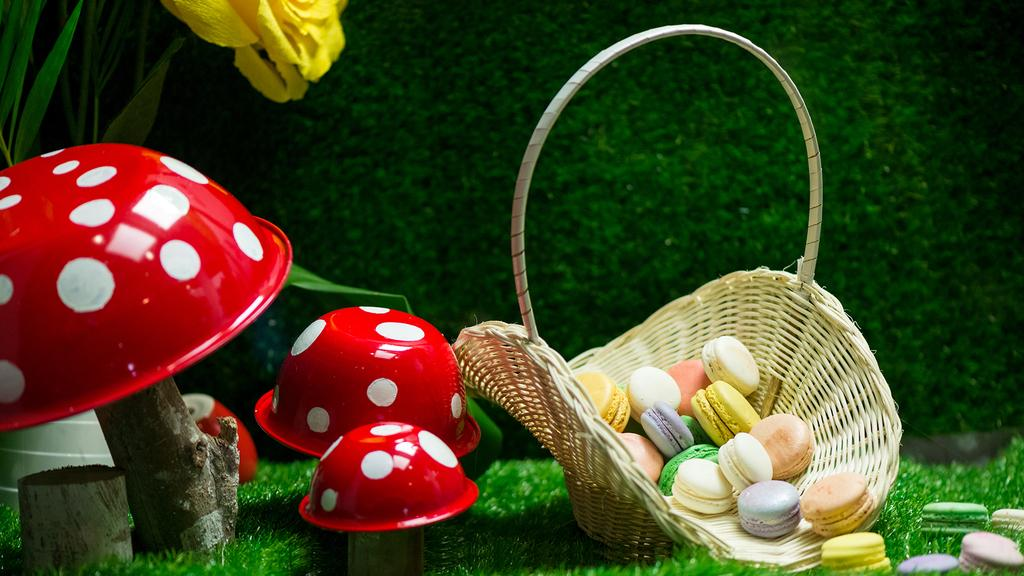What type of surface is at the bottom of the image? There is grass at the bottom of the image. What object can be seen in the image? There is a basket in the image. What is inside the basket? The basket contains products and toys. What can be seen in the background of the image? There are plants visible in the background of the image. How does the steam escape from the game in the image? There is no game or steam present in the image. Can you describe the kick of the creature in the image? There is no creature or kick present in the image. 